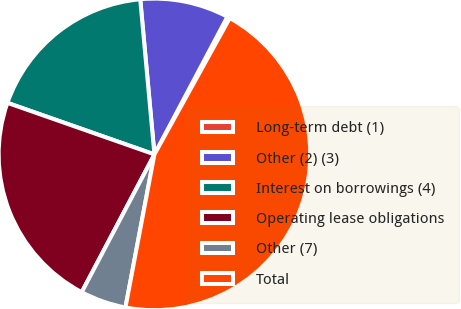Convert chart to OTSL. <chart><loc_0><loc_0><loc_500><loc_500><pie_chart><fcel>Long-term debt (1)<fcel>Other (2) (3)<fcel>Interest on borrowings (4)<fcel>Operating lease obligations<fcel>Other (7)<fcel>Total<nl><fcel>0.28%<fcel>9.21%<fcel>18.18%<fcel>22.64%<fcel>4.75%<fcel>44.94%<nl></chart> 